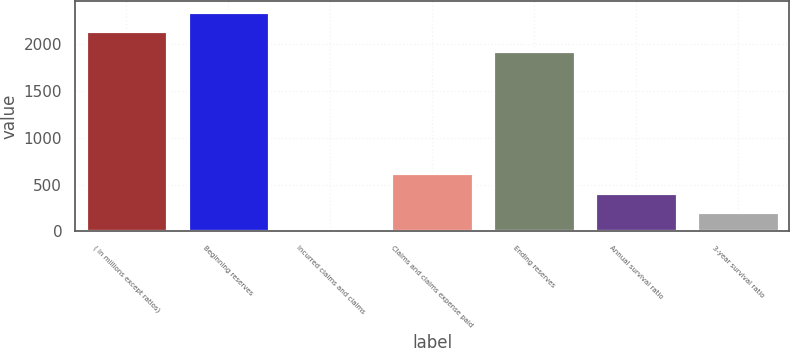Convert chart to OTSL. <chart><loc_0><loc_0><loc_500><loc_500><bar_chart><fcel>( in millions except ratios)<fcel>Beginning reserves<fcel>Incurred claims and claims<fcel>Claims and claims expense paid<fcel>Ending reserves<fcel>Annual survival ratio<fcel>3-year survival ratio<nl><fcel>2137.9<fcel>2342.8<fcel>4<fcel>618.7<fcel>1933<fcel>413.8<fcel>208.9<nl></chart> 